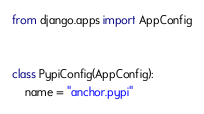Convert code to text. <code><loc_0><loc_0><loc_500><loc_500><_Python_>from django.apps import AppConfig


class PypiConfig(AppConfig):
    name = "anchor.pypi"
</code> 